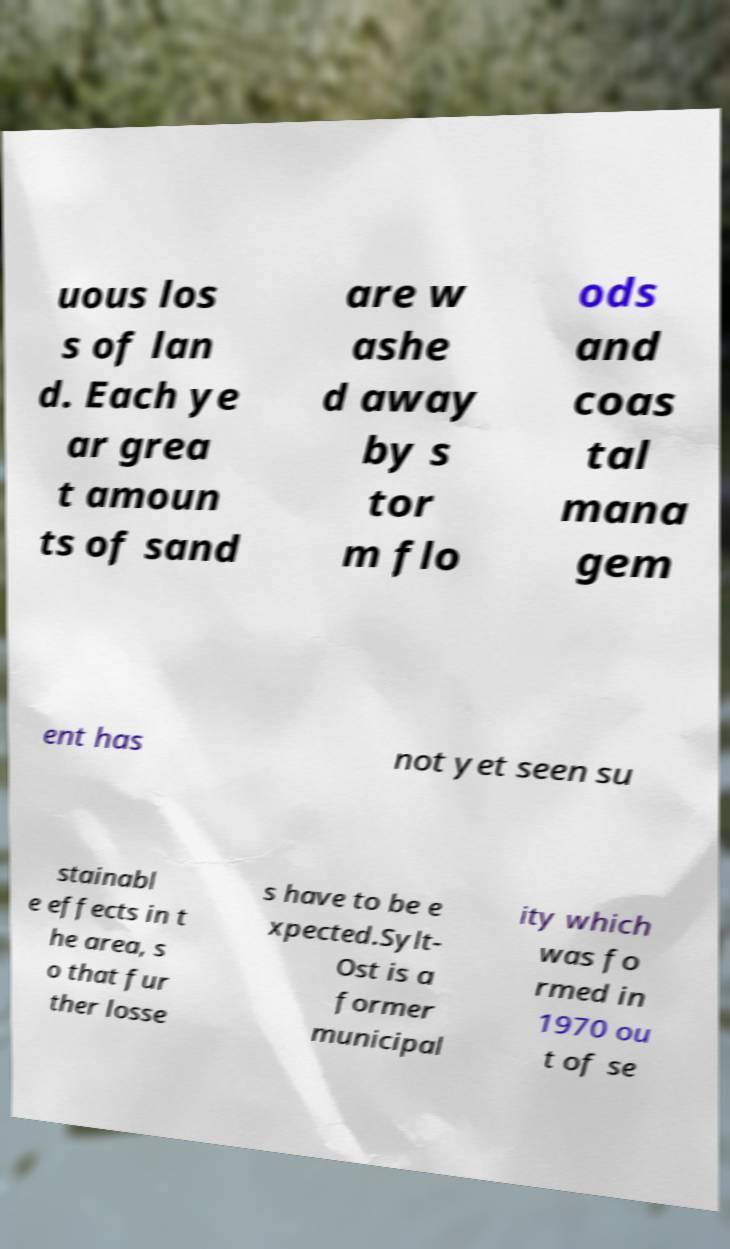Can you read and provide the text displayed in the image?This photo seems to have some interesting text. Can you extract and type it out for me? uous los s of lan d. Each ye ar grea t amoun ts of sand are w ashe d away by s tor m flo ods and coas tal mana gem ent has not yet seen su stainabl e effects in t he area, s o that fur ther losse s have to be e xpected.Sylt- Ost is a former municipal ity which was fo rmed in 1970 ou t of se 